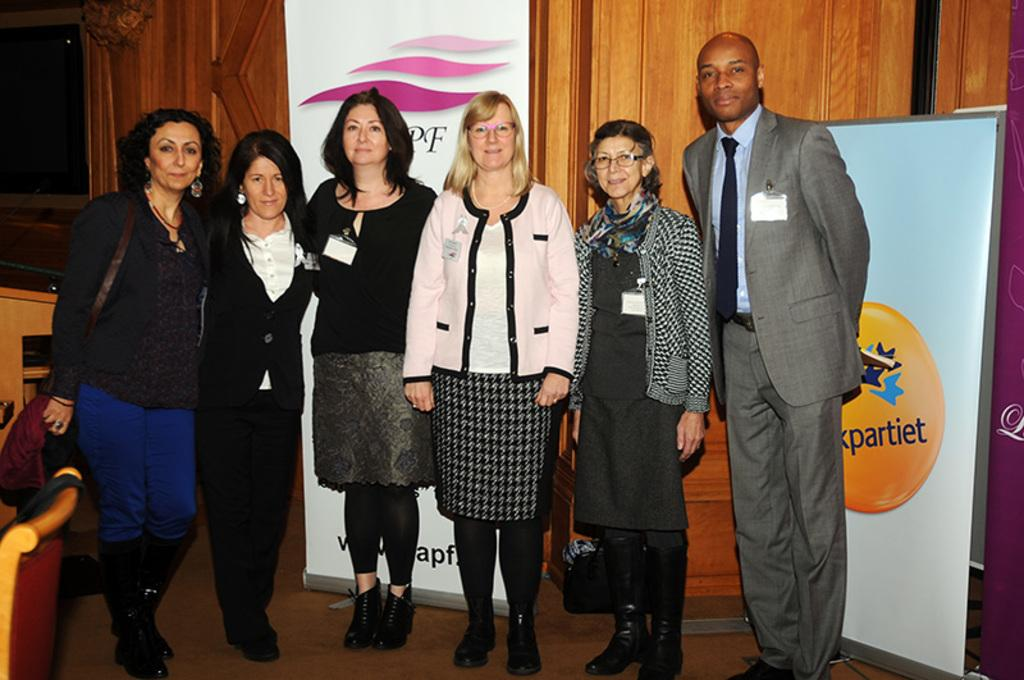What is happening in the image? There are people standing in the image. Can you describe the woman's attire? A woman is wearing a bag. Where is the chair located in the image? There is a chair in the bottom left of the image. What can be seen in the background of the image? Banners are visible in the background, along with a television and a wooden wall. How many beds are visible in the image? There are no beds present in the image. What day of the week is it in the image? The day of the week cannot be determined from the image. 